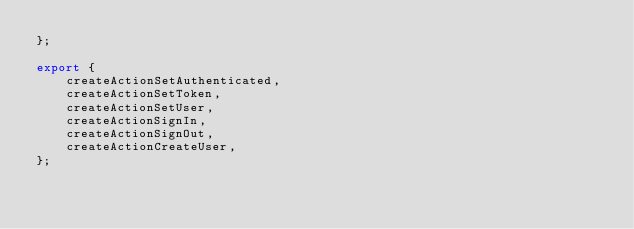Convert code to text. <code><loc_0><loc_0><loc_500><loc_500><_JavaScript_>};

export {
    createActionSetAuthenticated,
    createActionSetToken,
    createActionSetUser,
    createActionSignIn,
    createActionSignOut,
    createActionCreateUser,
};
</code> 